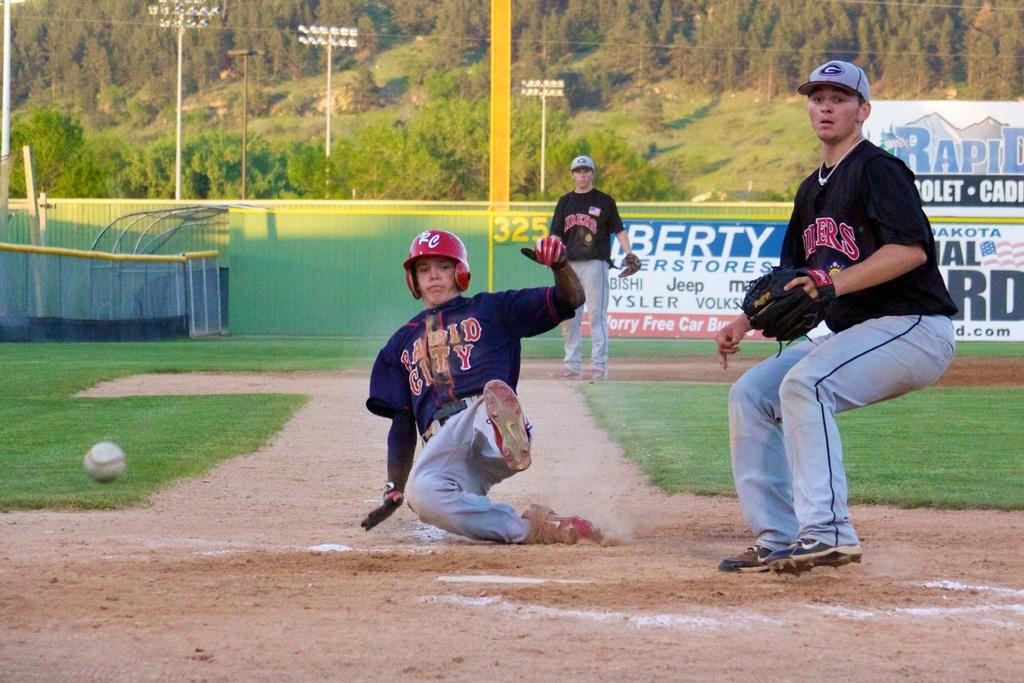Provide a one-sentence caption for the provided image. A baseball player for Rapid City is trying to slide into base before the player at the base catches the ball to tag him out. 